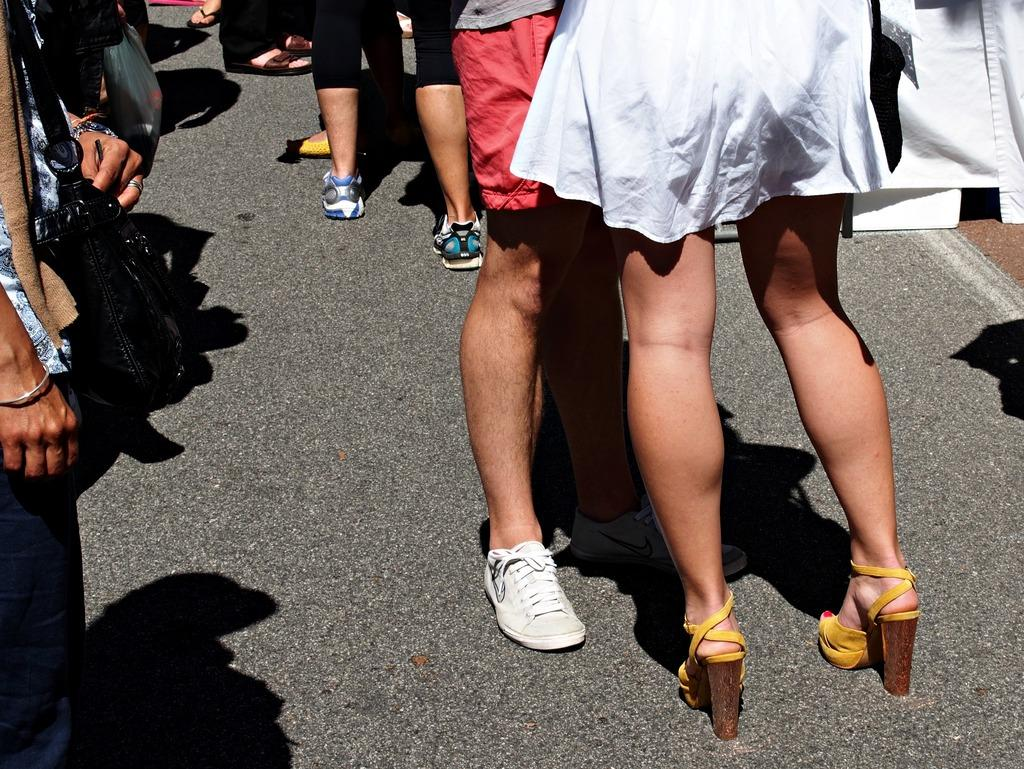What is happening in the image? There is a group of people in the image, and they are standing on a road. Can you describe any specific individuals in the group? Yes, there is a woman in the group, and she is wearing a white dress. What color are the woman's shoes? The woman's shoes are yellow. How much money is the woman holding in the image? There is no indication in the image that the woman is holding any money. What type of rat can be seen interacting with the woman in the image? There is no rat present in the image; it only features a group of people standing on a road. 